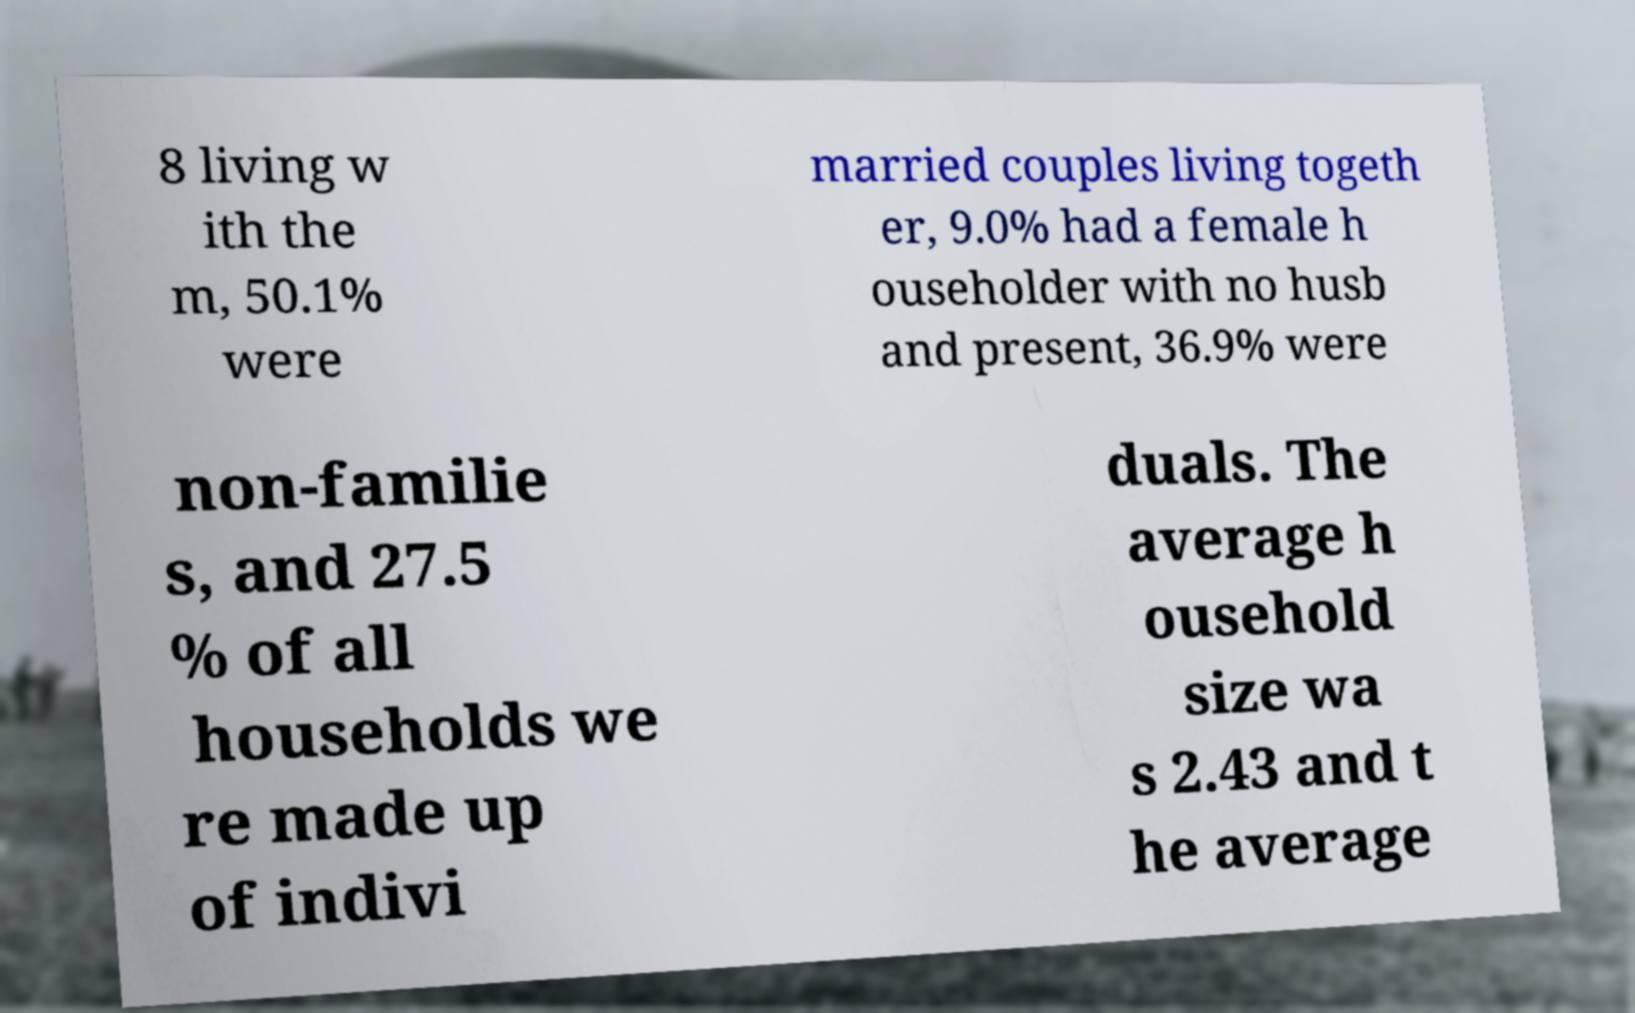There's text embedded in this image that I need extracted. Can you transcribe it verbatim? 8 living w ith the m, 50.1% were married couples living togeth er, 9.0% had a female h ouseholder with no husb and present, 36.9% were non-familie s, and 27.5 % of all households we re made up of indivi duals. The average h ousehold size wa s 2.43 and t he average 